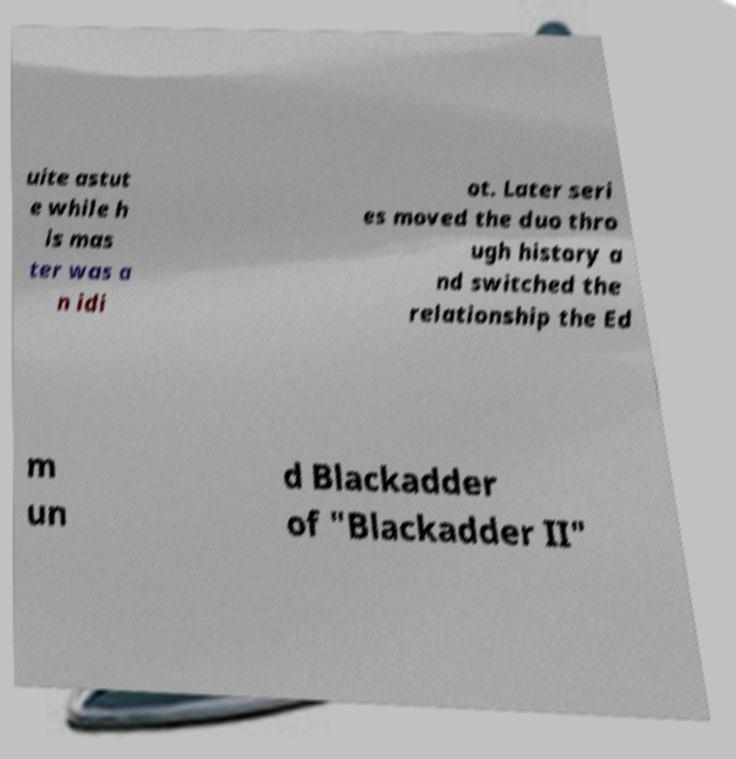Could you assist in decoding the text presented in this image and type it out clearly? uite astut e while h is mas ter was a n idi ot. Later seri es moved the duo thro ugh history a nd switched the relationship the Ed m un d Blackadder of "Blackadder II" 